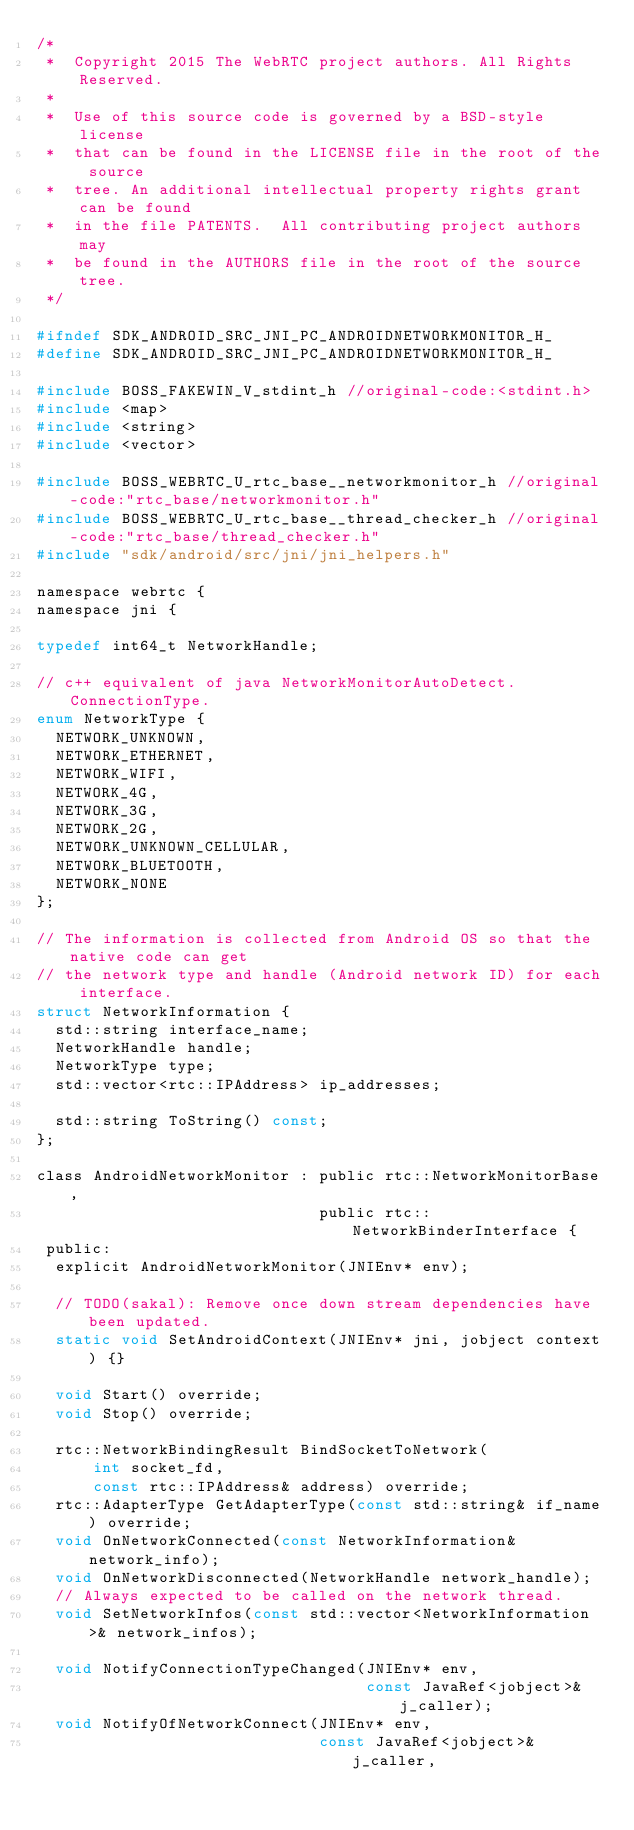Convert code to text. <code><loc_0><loc_0><loc_500><loc_500><_C_>/*
 *  Copyright 2015 The WebRTC project authors. All Rights Reserved.
 *
 *  Use of this source code is governed by a BSD-style license
 *  that can be found in the LICENSE file in the root of the source
 *  tree. An additional intellectual property rights grant can be found
 *  in the file PATENTS.  All contributing project authors may
 *  be found in the AUTHORS file in the root of the source tree.
 */

#ifndef SDK_ANDROID_SRC_JNI_PC_ANDROIDNETWORKMONITOR_H_
#define SDK_ANDROID_SRC_JNI_PC_ANDROIDNETWORKMONITOR_H_

#include BOSS_FAKEWIN_V_stdint_h //original-code:<stdint.h>
#include <map>
#include <string>
#include <vector>

#include BOSS_WEBRTC_U_rtc_base__networkmonitor_h //original-code:"rtc_base/networkmonitor.h"
#include BOSS_WEBRTC_U_rtc_base__thread_checker_h //original-code:"rtc_base/thread_checker.h"
#include "sdk/android/src/jni/jni_helpers.h"

namespace webrtc {
namespace jni {

typedef int64_t NetworkHandle;

// c++ equivalent of java NetworkMonitorAutoDetect.ConnectionType.
enum NetworkType {
  NETWORK_UNKNOWN,
  NETWORK_ETHERNET,
  NETWORK_WIFI,
  NETWORK_4G,
  NETWORK_3G,
  NETWORK_2G,
  NETWORK_UNKNOWN_CELLULAR,
  NETWORK_BLUETOOTH,
  NETWORK_NONE
};

// The information is collected from Android OS so that the native code can get
// the network type and handle (Android network ID) for each interface.
struct NetworkInformation {
  std::string interface_name;
  NetworkHandle handle;
  NetworkType type;
  std::vector<rtc::IPAddress> ip_addresses;

  std::string ToString() const;
};

class AndroidNetworkMonitor : public rtc::NetworkMonitorBase,
                              public rtc::NetworkBinderInterface {
 public:
  explicit AndroidNetworkMonitor(JNIEnv* env);

  // TODO(sakal): Remove once down stream dependencies have been updated.
  static void SetAndroidContext(JNIEnv* jni, jobject context) {}

  void Start() override;
  void Stop() override;

  rtc::NetworkBindingResult BindSocketToNetwork(
      int socket_fd,
      const rtc::IPAddress& address) override;
  rtc::AdapterType GetAdapterType(const std::string& if_name) override;
  void OnNetworkConnected(const NetworkInformation& network_info);
  void OnNetworkDisconnected(NetworkHandle network_handle);
  // Always expected to be called on the network thread.
  void SetNetworkInfos(const std::vector<NetworkInformation>& network_infos);

  void NotifyConnectionTypeChanged(JNIEnv* env,
                                   const JavaRef<jobject>& j_caller);
  void NotifyOfNetworkConnect(JNIEnv* env,
                              const JavaRef<jobject>& j_caller,</code> 